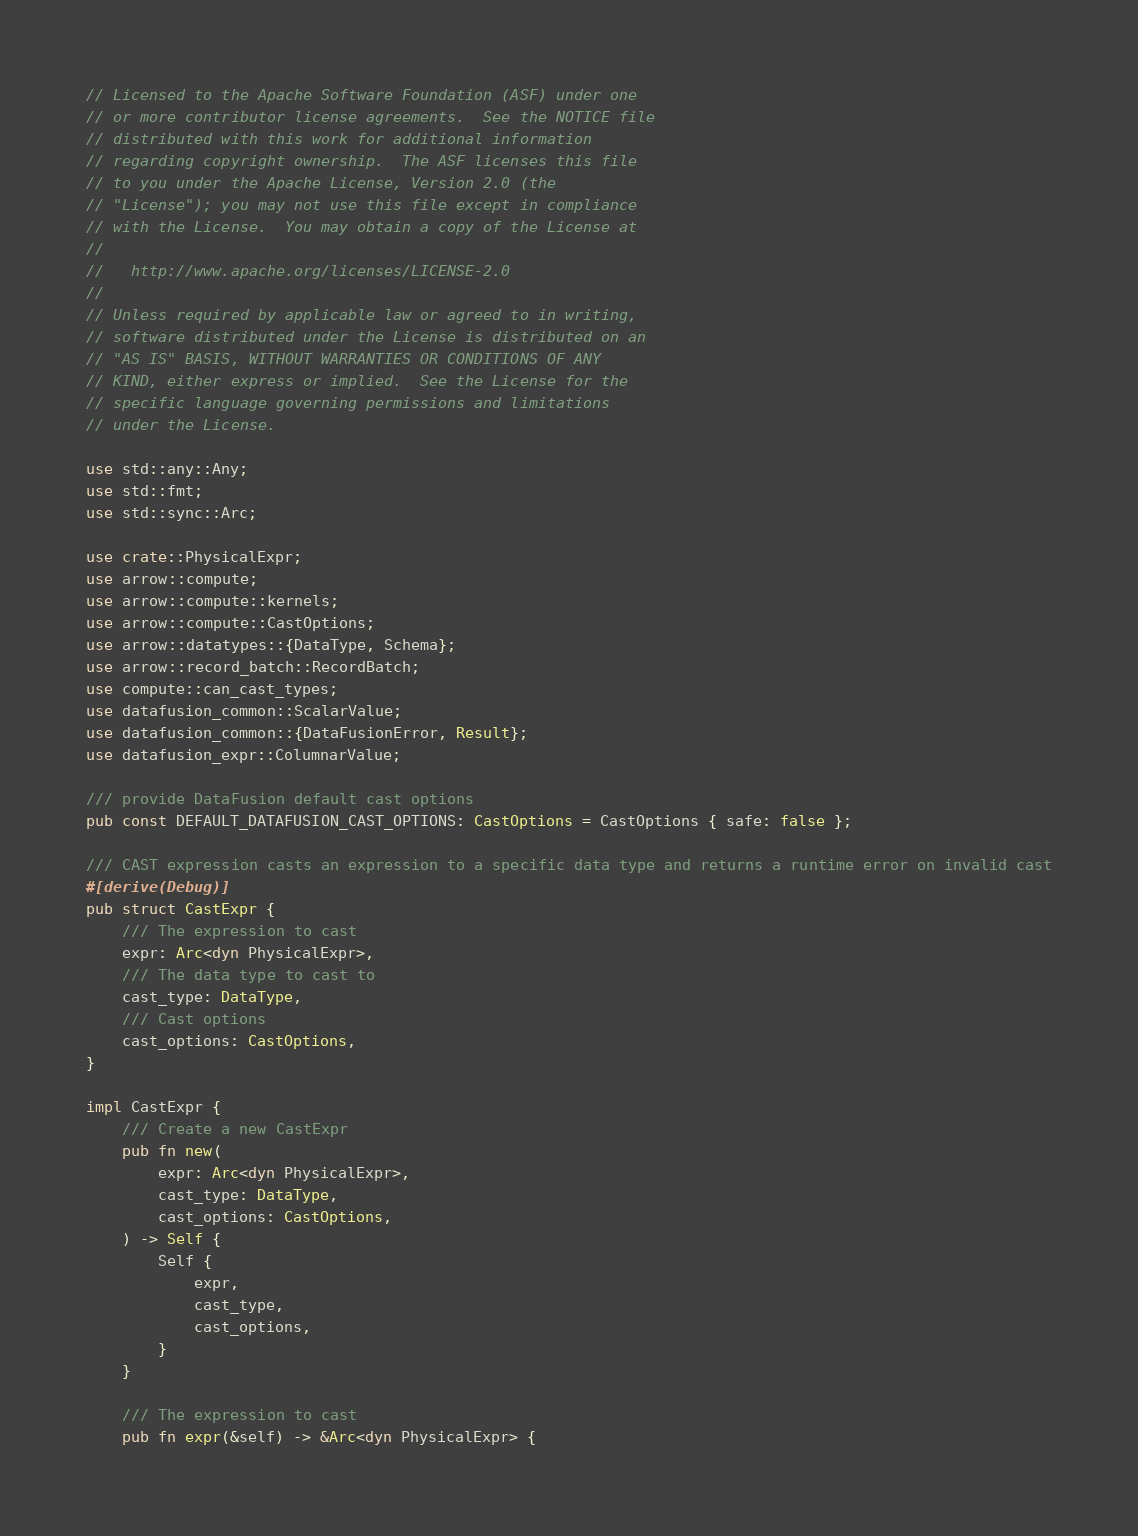<code> <loc_0><loc_0><loc_500><loc_500><_Rust_>// Licensed to the Apache Software Foundation (ASF) under one
// or more contributor license agreements.  See the NOTICE file
// distributed with this work for additional information
// regarding copyright ownership.  The ASF licenses this file
// to you under the Apache License, Version 2.0 (the
// "License"); you may not use this file except in compliance
// with the License.  You may obtain a copy of the License at
//
//   http://www.apache.org/licenses/LICENSE-2.0
//
// Unless required by applicable law or agreed to in writing,
// software distributed under the License is distributed on an
// "AS IS" BASIS, WITHOUT WARRANTIES OR CONDITIONS OF ANY
// KIND, either express or implied.  See the License for the
// specific language governing permissions and limitations
// under the License.

use std::any::Any;
use std::fmt;
use std::sync::Arc;

use crate::PhysicalExpr;
use arrow::compute;
use arrow::compute::kernels;
use arrow::compute::CastOptions;
use arrow::datatypes::{DataType, Schema};
use arrow::record_batch::RecordBatch;
use compute::can_cast_types;
use datafusion_common::ScalarValue;
use datafusion_common::{DataFusionError, Result};
use datafusion_expr::ColumnarValue;

/// provide DataFusion default cast options
pub const DEFAULT_DATAFUSION_CAST_OPTIONS: CastOptions = CastOptions { safe: false };

/// CAST expression casts an expression to a specific data type and returns a runtime error on invalid cast
#[derive(Debug)]
pub struct CastExpr {
    /// The expression to cast
    expr: Arc<dyn PhysicalExpr>,
    /// The data type to cast to
    cast_type: DataType,
    /// Cast options
    cast_options: CastOptions,
}

impl CastExpr {
    /// Create a new CastExpr
    pub fn new(
        expr: Arc<dyn PhysicalExpr>,
        cast_type: DataType,
        cast_options: CastOptions,
    ) -> Self {
        Self {
            expr,
            cast_type,
            cast_options,
        }
    }

    /// The expression to cast
    pub fn expr(&self) -> &Arc<dyn PhysicalExpr> {</code> 